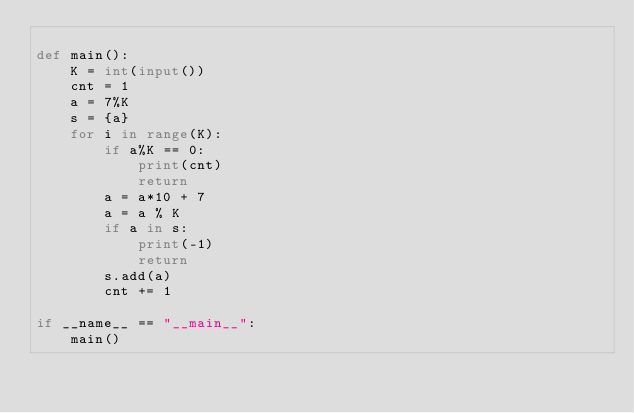Convert code to text. <code><loc_0><loc_0><loc_500><loc_500><_Python_>
def main():
    K = int(input())
    cnt = 1
    a = 7%K
    s = {a}
    for i in range(K):
        if a%K == 0:
            print(cnt)
            return
        a = a*10 + 7
        a = a % K
        if a in s:
            print(-1)
            return
        s.add(a)
        cnt += 1

if __name__ == "__main__":
    main()</code> 